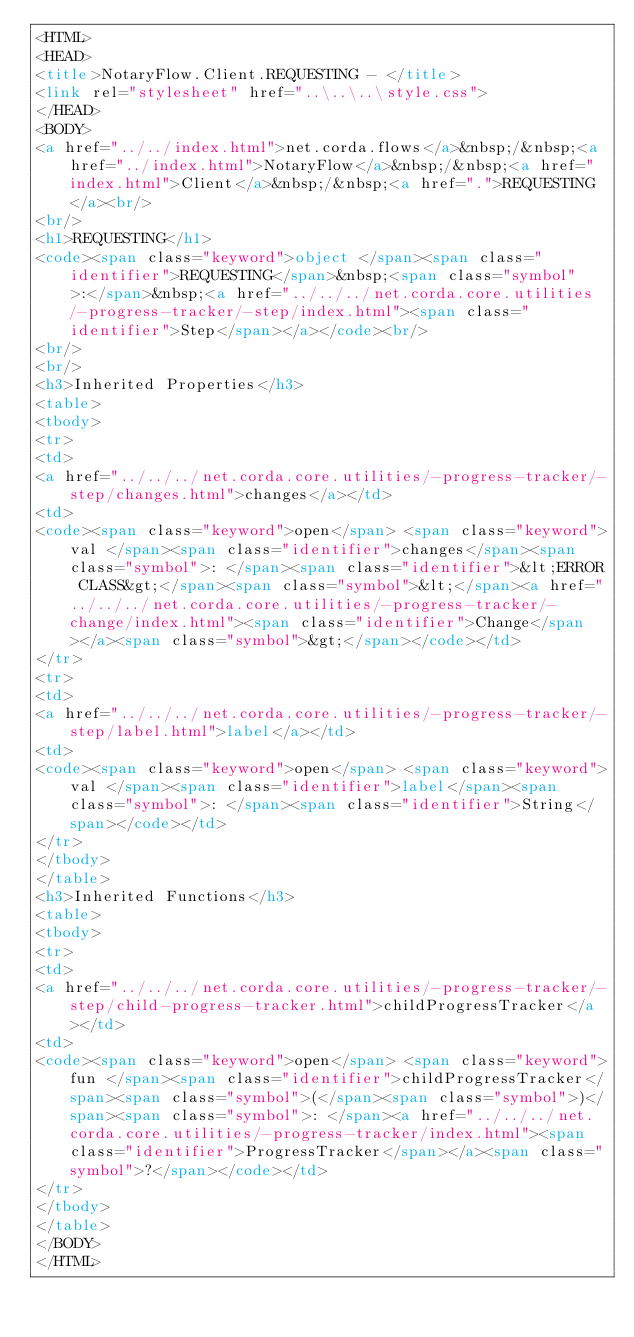Convert code to text. <code><loc_0><loc_0><loc_500><loc_500><_HTML_><HTML>
<HEAD>
<title>NotaryFlow.Client.REQUESTING - </title>
<link rel="stylesheet" href="..\..\..\style.css">
</HEAD>
<BODY>
<a href="../../index.html">net.corda.flows</a>&nbsp;/&nbsp;<a href="../index.html">NotaryFlow</a>&nbsp;/&nbsp;<a href="index.html">Client</a>&nbsp;/&nbsp;<a href=".">REQUESTING</a><br/>
<br/>
<h1>REQUESTING</h1>
<code><span class="keyword">object </span><span class="identifier">REQUESTING</span>&nbsp;<span class="symbol">:</span>&nbsp;<a href="../../../net.corda.core.utilities/-progress-tracker/-step/index.html"><span class="identifier">Step</span></a></code><br/>
<br/>
<br/>
<h3>Inherited Properties</h3>
<table>
<tbody>
<tr>
<td>
<a href="../../../net.corda.core.utilities/-progress-tracker/-step/changes.html">changes</a></td>
<td>
<code><span class="keyword">open</span> <span class="keyword">val </span><span class="identifier">changes</span><span class="symbol">: </span><span class="identifier">&lt;ERROR CLASS&gt;</span><span class="symbol">&lt;</span><a href="../../../net.corda.core.utilities/-progress-tracker/-change/index.html"><span class="identifier">Change</span></a><span class="symbol">&gt;</span></code></td>
</tr>
<tr>
<td>
<a href="../../../net.corda.core.utilities/-progress-tracker/-step/label.html">label</a></td>
<td>
<code><span class="keyword">open</span> <span class="keyword">val </span><span class="identifier">label</span><span class="symbol">: </span><span class="identifier">String</span></code></td>
</tr>
</tbody>
</table>
<h3>Inherited Functions</h3>
<table>
<tbody>
<tr>
<td>
<a href="../../../net.corda.core.utilities/-progress-tracker/-step/child-progress-tracker.html">childProgressTracker</a></td>
<td>
<code><span class="keyword">open</span> <span class="keyword">fun </span><span class="identifier">childProgressTracker</span><span class="symbol">(</span><span class="symbol">)</span><span class="symbol">: </span><a href="../../../net.corda.core.utilities/-progress-tracker/index.html"><span class="identifier">ProgressTracker</span></a><span class="symbol">?</span></code></td>
</tr>
</tbody>
</table>
</BODY>
</HTML>
</code> 